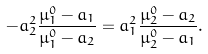Convert formula to latex. <formula><loc_0><loc_0><loc_500><loc_500>- a _ { 2 } ^ { 2 } \frac { \mu _ { 1 } ^ { 0 } - a _ { 1 } } { \mu _ { 1 } ^ { 0 } - a _ { 2 } } = a _ { 1 } ^ { 2 } \frac { \mu _ { 2 } ^ { 0 } - a _ { 2 } } { \mu _ { 2 } ^ { 0 } - a _ { 1 } } .</formula> 